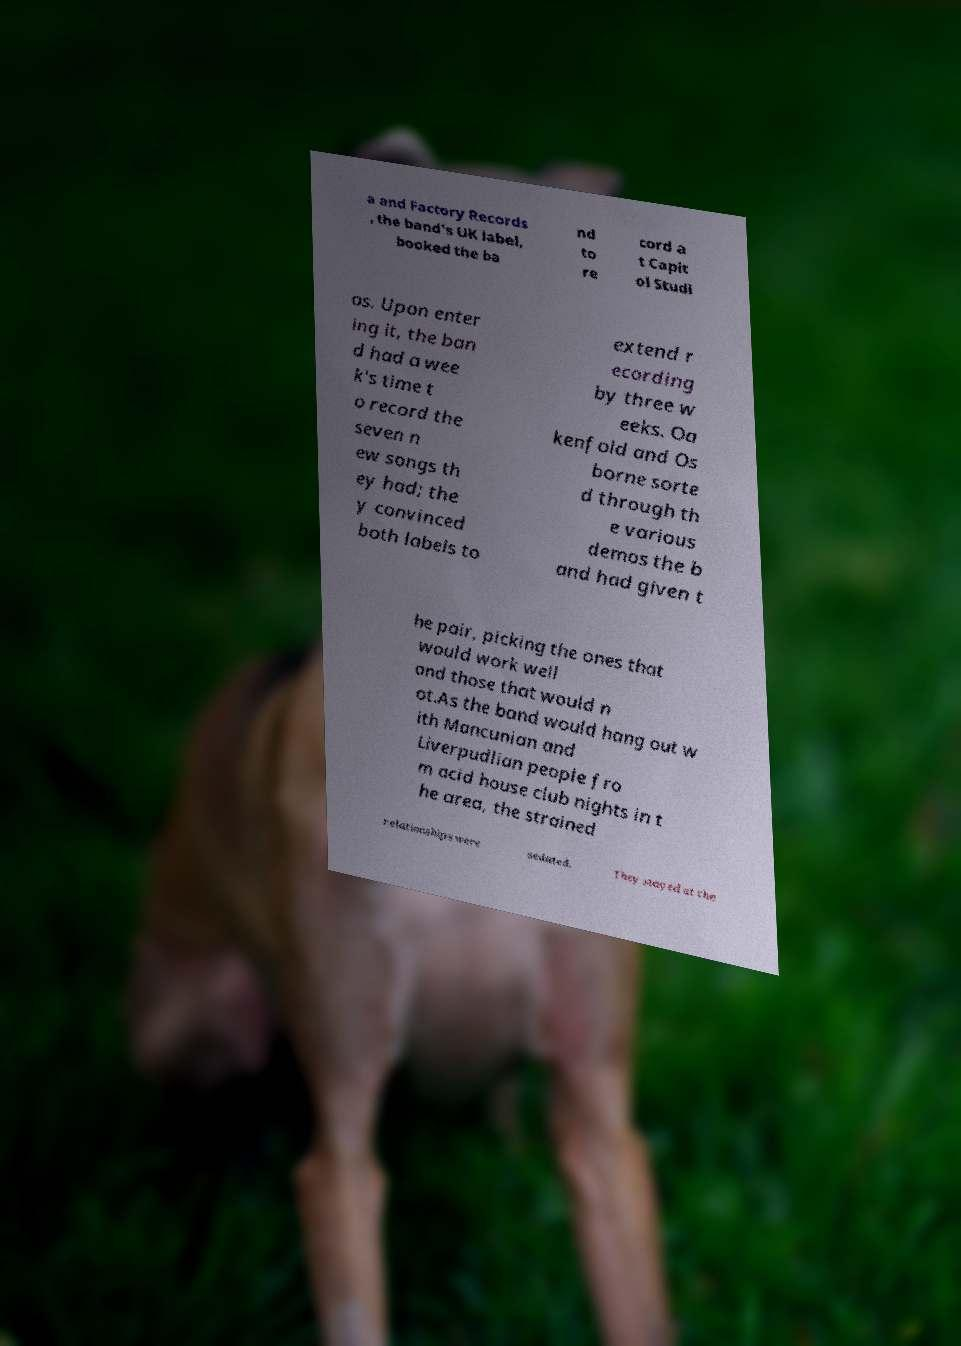Can you accurately transcribe the text from the provided image for me? a and Factory Records , the band's UK label, booked the ba nd to re cord a t Capit ol Studi os. Upon enter ing it, the ban d had a wee k's time t o record the seven n ew songs th ey had; the y convinced both labels to extend r ecording by three w eeks. Oa kenfold and Os borne sorte d through th e various demos the b and had given t he pair, picking the ones that would work well and those that would n ot.As the band would hang out w ith Mancunian and Liverpudlian people fro m acid house club nights in t he area, the strained relationships were sedated. They stayed at the 